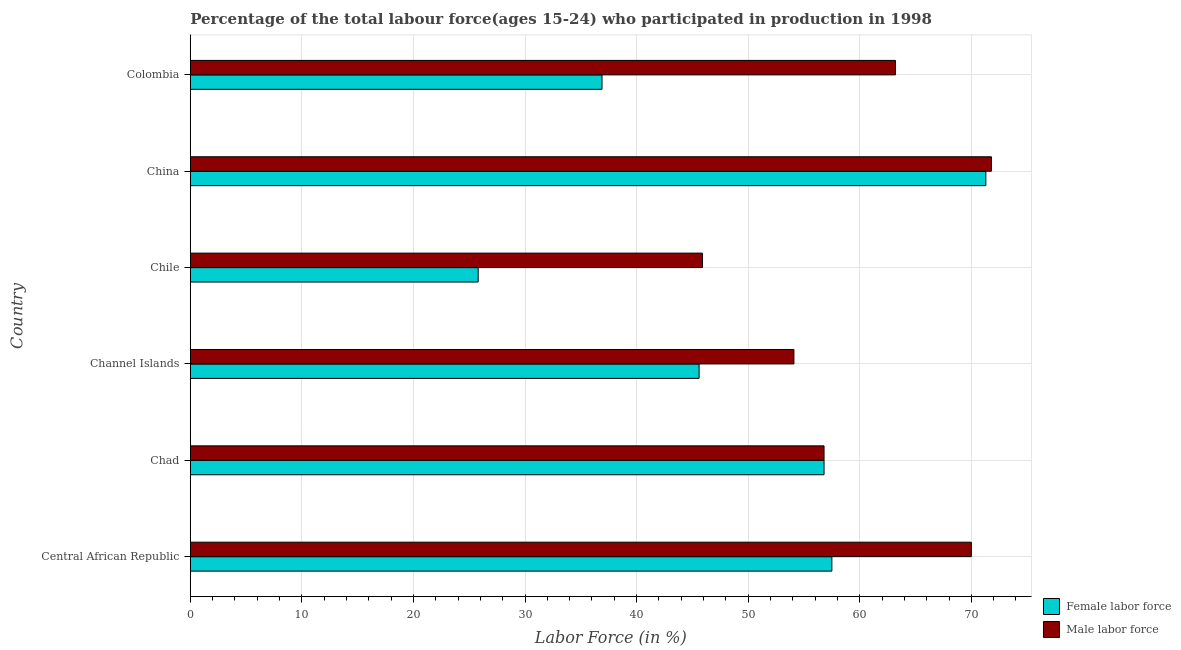How many groups of bars are there?
Your answer should be compact. 6. Are the number of bars per tick equal to the number of legend labels?
Offer a terse response. Yes. How many bars are there on the 2nd tick from the top?
Provide a short and direct response. 2. What is the label of the 6th group of bars from the top?
Make the answer very short. Central African Republic. What is the percentage of male labour force in China?
Your answer should be compact. 71.8. Across all countries, what is the maximum percentage of male labour force?
Your answer should be very brief. 71.8. Across all countries, what is the minimum percentage of female labor force?
Your answer should be compact. 25.8. In which country was the percentage of female labor force maximum?
Keep it short and to the point. China. In which country was the percentage of male labour force minimum?
Make the answer very short. Chile. What is the total percentage of female labor force in the graph?
Provide a short and direct response. 293.9. What is the difference between the percentage of male labour force in Channel Islands and that in Colombia?
Ensure brevity in your answer.  -9.1. What is the difference between the percentage of female labor force in China and the percentage of male labour force in Central African Republic?
Offer a terse response. 1.3. What is the average percentage of female labor force per country?
Make the answer very short. 48.98. In how many countries, is the percentage of female labor force greater than 70 %?
Make the answer very short. 1. What is the ratio of the percentage of male labour force in Chad to that in Chile?
Provide a short and direct response. 1.24. What is the difference between the highest and the second highest percentage of male labour force?
Offer a very short reply. 1.8. What is the difference between the highest and the lowest percentage of male labour force?
Your answer should be very brief. 25.9. Is the sum of the percentage of female labor force in Central African Republic and Channel Islands greater than the maximum percentage of male labour force across all countries?
Make the answer very short. Yes. What does the 2nd bar from the top in China represents?
Your response must be concise. Female labor force. What does the 2nd bar from the bottom in Chad represents?
Make the answer very short. Male labor force. Are all the bars in the graph horizontal?
Ensure brevity in your answer.  Yes. Are the values on the major ticks of X-axis written in scientific E-notation?
Make the answer very short. No. Does the graph contain any zero values?
Keep it short and to the point. No. Does the graph contain grids?
Keep it short and to the point. Yes. How many legend labels are there?
Ensure brevity in your answer.  2. How are the legend labels stacked?
Ensure brevity in your answer.  Vertical. What is the title of the graph?
Keep it short and to the point. Percentage of the total labour force(ages 15-24) who participated in production in 1998. What is the label or title of the X-axis?
Offer a terse response. Labor Force (in %). What is the label or title of the Y-axis?
Your response must be concise. Country. What is the Labor Force (in %) of Female labor force in Central African Republic?
Ensure brevity in your answer.  57.5. What is the Labor Force (in %) in Male labor force in Central African Republic?
Keep it short and to the point. 70. What is the Labor Force (in %) of Female labor force in Chad?
Provide a short and direct response. 56.8. What is the Labor Force (in %) of Male labor force in Chad?
Offer a very short reply. 56.8. What is the Labor Force (in %) in Female labor force in Channel Islands?
Ensure brevity in your answer.  45.6. What is the Labor Force (in %) in Male labor force in Channel Islands?
Your answer should be compact. 54.1. What is the Labor Force (in %) of Female labor force in Chile?
Offer a very short reply. 25.8. What is the Labor Force (in %) in Male labor force in Chile?
Keep it short and to the point. 45.9. What is the Labor Force (in %) of Female labor force in China?
Keep it short and to the point. 71.3. What is the Labor Force (in %) of Male labor force in China?
Your answer should be compact. 71.8. What is the Labor Force (in %) of Female labor force in Colombia?
Your answer should be very brief. 36.9. What is the Labor Force (in %) of Male labor force in Colombia?
Your answer should be compact. 63.2. Across all countries, what is the maximum Labor Force (in %) of Female labor force?
Your answer should be very brief. 71.3. Across all countries, what is the maximum Labor Force (in %) of Male labor force?
Offer a terse response. 71.8. Across all countries, what is the minimum Labor Force (in %) of Female labor force?
Your response must be concise. 25.8. Across all countries, what is the minimum Labor Force (in %) in Male labor force?
Your response must be concise. 45.9. What is the total Labor Force (in %) in Female labor force in the graph?
Give a very brief answer. 293.9. What is the total Labor Force (in %) in Male labor force in the graph?
Make the answer very short. 361.8. What is the difference between the Labor Force (in %) in Female labor force in Central African Republic and that in Channel Islands?
Your answer should be compact. 11.9. What is the difference between the Labor Force (in %) in Female labor force in Central African Republic and that in Chile?
Provide a short and direct response. 31.7. What is the difference between the Labor Force (in %) of Male labor force in Central African Republic and that in Chile?
Keep it short and to the point. 24.1. What is the difference between the Labor Force (in %) in Female labor force in Central African Republic and that in Colombia?
Your answer should be very brief. 20.6. What is the difference between the Labor Force (in %) in Male labor force in Central African Republic and that in Colombia?
Make the answer very short. 6.8. What is the difference between the Labor Force (in %) of Female labor force in Chad and that in Channel Islands?
Offer a terse response. 11.2. What is the difference between the Labor Force (in %) in Male labor force in Chad and that in Channel Islands?
Give a very brief answer. 2.7. What is the difference between the Labor Force (in %) of Female labor force in Chad and that in Chile?
Your answer should be very brief. 31. What is the difference between the Labor Force (in %) in Female labor force in Chad and that in China?
Provide a succinct answer. -14.5. What is the difference between the Labor Force (in %) in Male labor force in Chad and that in China?
Your answer should be compact. -15. What is the difference between the Labor Force (in %) in Female labor force in Chad and that in Colombia?
Your answer should be very brief. 19.9. What is the difference between the Labor Force (in %) of Male labor force in Chad and that in Colombia?
Ensure brevity in your answer.  -6.4. What is the difference between the Labor Force (in %) of Female labor force in Channel Islands and that in Chile?
Ensure brevity in your answer.  19.8. What is the difference between the Labor Force (in %) in Male labor force in Channel Islands and that in Chile?
Offer a terse response. 8.2. What is the difference between the Labor Force (in %) of Female labor force in Channel Islands and that in China?
Make the answer very short. -25.7. What is the difference between the Labor Force (in %) in Male labor force in Channel Islands and that in China?
Give a very brief answer. -17.7. What is the difference between the Labor Force (in %) of Female labor force in Chile and that in China?
Provide a short and direct response. -45.5. What is the difference between the Labor Force (in %) of Male labor force in Chile and that in China?
Your answer should be very brief. -25.9. What is the difference between the Labor Force (in %) in Female labor force in Chile and that in Colombia?
Keep it short and to the point. -11.1. What is the difference between the Labor Force (in %) in Male labor force in Chile and that in Colombia?
Offer a very short reply. -17.3. What is the difference between the Labor Force (in %) of Female labor force in China and that in Colombia?
Make the answer very short. 34.4. What is the difference between the Labor Force (in %) in Male labor force in China and that in Colombia?
Keep it short and to the point. 8.6. What is the difference between the Labor Force (in %) of Female labor force in Central African Republic and the Labor Force (in %) of Male labor force in Chad?
Give a very brief answer. 0.7. What is the difference between the Labor Force (in %) of Female labor force in Central African Republic and the Labor Force (in %) of Male labor force in Channel Islands?
Provide a short and direct response. 3.4. What is the difference between the Labor Force (in %) in Female labor force in Central African Republic and the Labor Force (in %) in Male labor force in China?
Provide a succinct answer. -14.3. What is the difference between the Labor Force (in %) of Female labor force in Chad and the Labor Force (in %) of Male labor force in Chile?
Provide a succinct answer. 10.9. What is the difference between the Labor Force (in %) of Female labor force in Channel Islands and the Labor Force (in %) of Male labor force in China?
Your answer should be very brief. -26.2. What is the difference between the Labor Force (in %) in Female labor force in Channel Islands and the Labor Force (in %) in Male labor force in Colombia?
Offer a very short reply. -17.6. What is the difference between the Labor Force (in %) in Female labor force in Chile and the Labor Force (in %) in Male labor force in China?
Your answer should be compact. -46. What is the difference between the Labor Force (in %) of Female labor force in Chile and the Labor Force (in %) of Male labor force in Colombia?
Give a very brief answer. -37.4. What is the difference between the Labor Force (in %) of Female labor force in China and the Labor Force (in %) of Male labor force in Colombia?
Give a very brief answer. 8.1. What is the average Labor Force (in %) in Female labor force per country?
Your answer should be compact. 48.98. What is the average Labor Force (in %) of Male labor force per country?
Keep it short and to the point. 60.3. What is the difference between the Labor Force (in %) of Female labor force and Labor Force (in %) of Male labor force in Chad?
Offer a terse response. 0. What is the difference between the Labor Force (in %) in Female labor force and Labor Force (in %) in Male labor force in Channel Islands?
Ensure brevity in your answer.  -8.5. What is the difference between the Labor Force (in %) of Female labor force and Labor Force (in %) of Male labor force in Chile?
Offer a very short reply. -20.1. What is the difference between the Labor Force (in %) in Female labor force and Labor Force (in %) in Male labor force in Colombia?
Your response must be concise. -26.3. What is the ratio of the Labor Force (in %) of Female labor force in Central African Republic to that in Chad?
Make the answer very short. 1.01. What is the ratio of the Labor Force (in %) of Male labor force in Central African Republic to that in Chad?
Provide a short and direct response. 1.23. What is the ratio of the Labor Force (in %) of Female labor force in Central African Republic to that in Channel Islands?
Ensure brevity in your answer.  1.26. What is the ratio of the Labor Force (in %) in Male labor force in Central African Republic to that in Channel Islands?
Offer a terse response. 1.29. What is the ratio of the Labor Force (in %) of Female labor force in Central African Republic to that in Chile?
Keep it short and to the point. 2.23. What is the ratio of the Labor Force (in %) in Male labor force in Central African Republic to that in Chile?
Ensure brevity in your answer.  1.53. What is the ratio of the Labor Force (in %) in Female labor force in Central African Republic to that in China?
Keep it short and to the point. 0.81. What is the ratio of the Labor Force (in %) of Male labor force in Central African Republic to that in China?
Your answer should be compact. 0.97. What is the ratio of the Labor Force (in %) of Female labor force in Central African Republic to that in Colombia?
Provide a succinct answer. 1.56. What is the ratio of the Labor Force (in %) in Male labor force in Central African Republic to that in Colombia?
Your answer should be very brief. 1.11. What is the ratio of the Labor Force (in %) in Female labor force in Chad to that in Channel Islands?
Keep it short and to the point. 1.25. What is the ratio of the Labor Force (in %) of Male labor force in Chad to that in Channel Islands?
Offer a very short reply. 1.05. What is the ratio of the Labor Force (in %) of Female labor force in Chad to that in Chile?
Keep it short and to the point. 2.2. What is the ratio of the Labor Force (in %) in Male labor force in Chad to that in Chile?
Provide a succinct answer. 1.24. What is the ratio of the Labor Force (in %) of Female labor force in Chad to that in China?
Offer a terse response. 0.8. What is the ratio of the Labor Force (in %) of Male labor force in Chad to that in China?
Your answer should be compact. 0.79. What is the ratio of the Labor Force (in %) in Female labor force in Chad to that in Colombia?
Provide a short and direct response. 1.54. What is the ratio of the Labor Force (in %) of Male labor force in Chad to that in Colombia?
Make the answer very short. 0.9. What is the ratio of the Labor Force (in %) of Female labor force in Channel Islands to that in Chile?
Offer a terse response. 1.77. What is the ratio of the Labor Force (in %) of Male labor force in Channel Islands to that in Chile?
Ensure brevity in your answer.  1.18. What is the ratio of the Labor Force (in %) in Female labor force in Channel Islands to that in China?
Give a very brief answer. 0.64. What is the ratio of the Labor Force (in %) in Male labor force in Channel Islands to that in China?
Offer a very short reply. 0.75. What is the ratio of the Labor Force (in %) in Female labor force in Channel Islands to that in Colombia?
Keep it short and to the point. 1.24. What is the ratio of the Labor Force (in %) in Male labor force in Channel Islands to that in Colombia?
Provide a succinct answer. 0.86. What is the ratio of the Labor Force (in %) of Female labor force in Chile to that in China?
Provide a short and direct response. 0.36. What is the ratio of the Labor Force (in %) in Male labor force in Chile to that in China?
Your response must be concise. 0.64. What is the ratio of the Labor Force (in %) in Female labor force in Chile to that in Colombia?
Give a very brief answer. 0.7. What is the ratio of the Labor Force (in %) of Male labor force in Chile to that in Colombia?
Offer a terse response. 0.73. What is the ratio of the Labor Force (in %) in Female labor force in China to that in Colombia?
Your answer should be very brief. 1.93. What is the ratio of the Labor Force (in %) of Male labor force in China to that in Colombia?
Your answer should be compact. 1.14. What is the difference between the highest and the lowest Labor Force (in %) in Female labor force?
Provide a succinct answer. 45.5. What is the difference between the highest and the lowest Labor Force (in %) of Male labor force?
Offer a terse response. 25.9. 